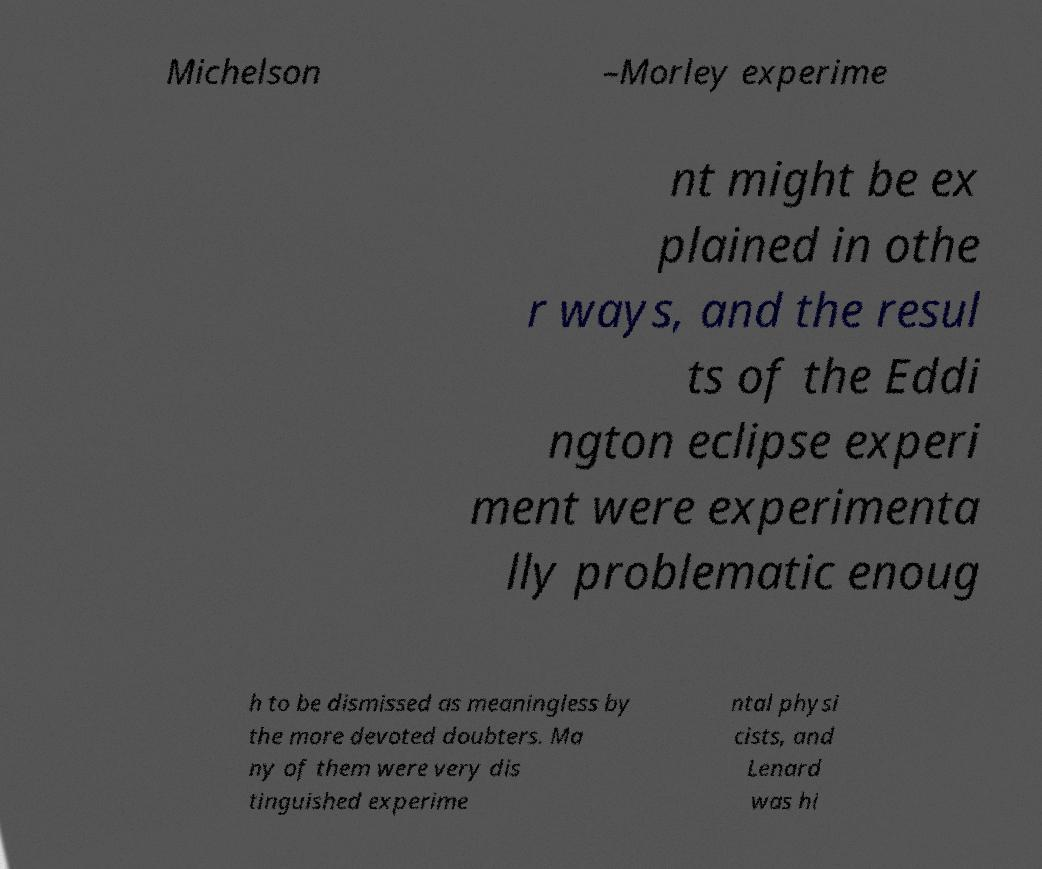Can you read and provide the text displayed in the image?This photo seems to have some interesting text. Can you extract and type it out for me? Michelson –Morley experime nt might be ex plained in othe r ways, and the resul ts of the Eddi ngton eclipse experi ment were experimenta lly problematic enoug h to be dismissed as meaningless by the more devoted doubters. Ma ny of them were very dis tinguished experime ntal physi cists, and Lenard was hi 